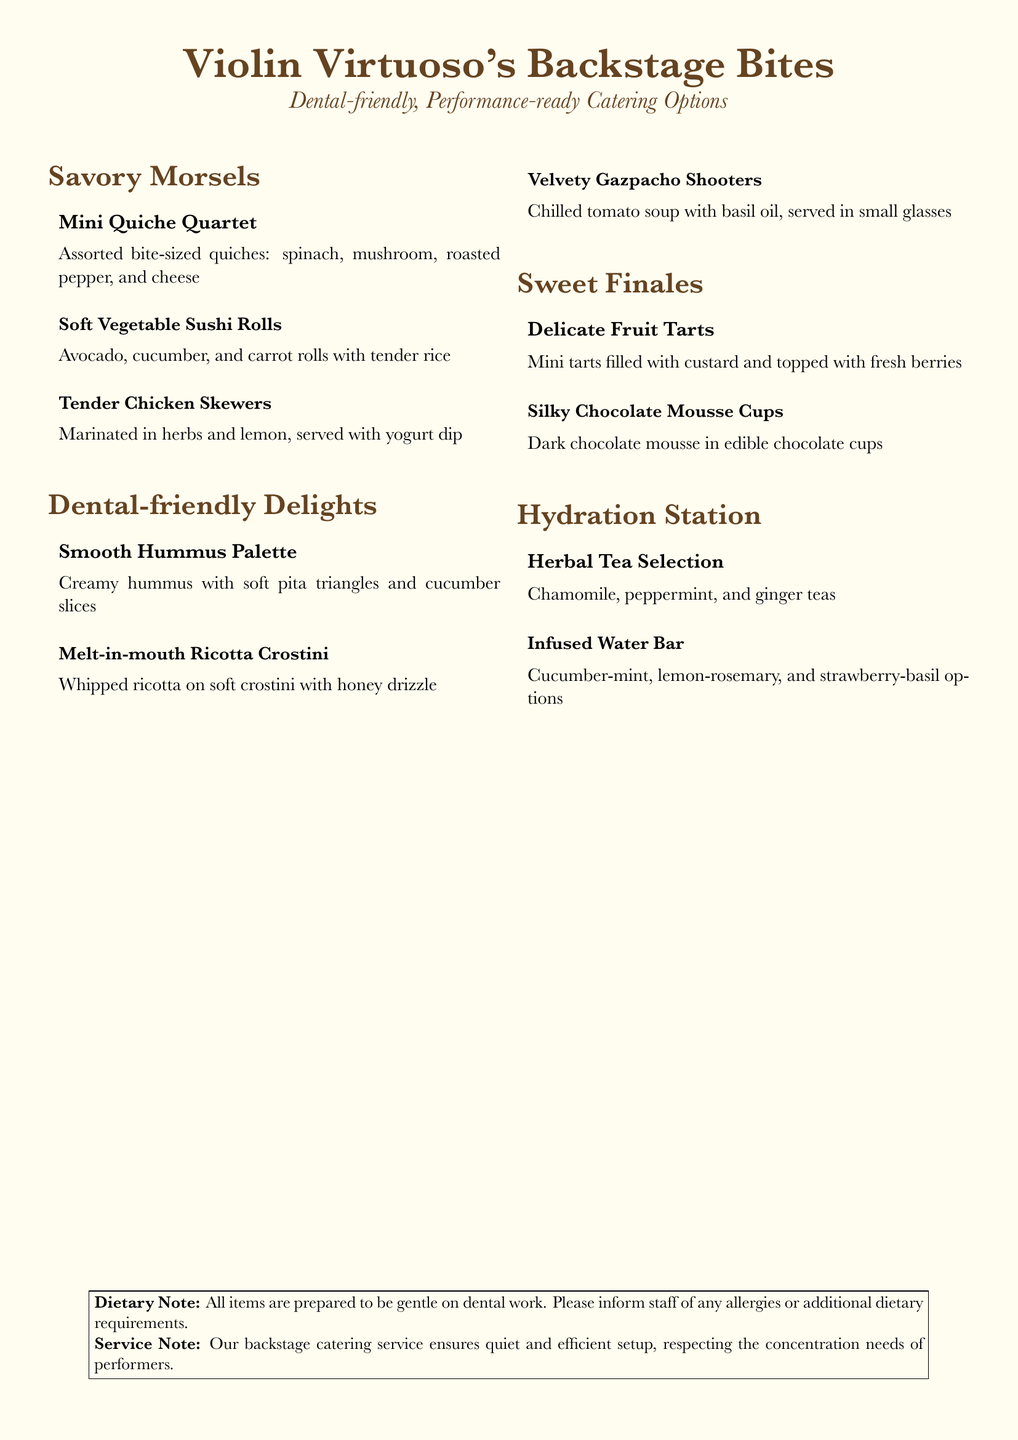What is the title of the menu? The title of the menu is displayed prominently at the top of the document and is "Violin Virtuoso's Backstage Bites."
Answer: Violin Virtuoso's Backstage Bites How many sections are in the menu? The menu is divided into four sections: Savory Morsels, Dental-friendly Delights, Sweet Finales, and Hydration Station.
Answer: Four What are the ingredients of the soft vegetable sushi rolls? The ingredients are listed in the menu item description for soft vegetable sushi rolls as avocado, cucumber, and carrot.
Answer: Avocado, cucumber, and carrot What kind of tea is included in the Herbal Tea Selection? The Herbal Tea Selection includes three types of tea stated in the menu: chamomile, peppermint, and ginger.
Answer: Chamomile, peppermint, and ginger Which item is served with a yogurt dip? The Tender Chicken Skewers are specifically mentioned to be served with yogurt dip in their description.
Answer: Tender Chicken Skewers What type of dessert features fresh berries? The dessert that features fresh berries is the Delicate Fruit Tarts, as mentioned in its description.
Answer: Delicate Fruit Tarts What is the main purpose of the catering service? The main purpose of the catering service, noted in the document, is to ensure a quiet and efficient setup respecting performers' concentration.
Answer: Efficient setup Are the items prepared with dietary restrictions in mind? Yes, the menu includes a note indicating that all items are prepared to be gentle on dental work and recommends informing staff of any allergies.
Answer: Yes 